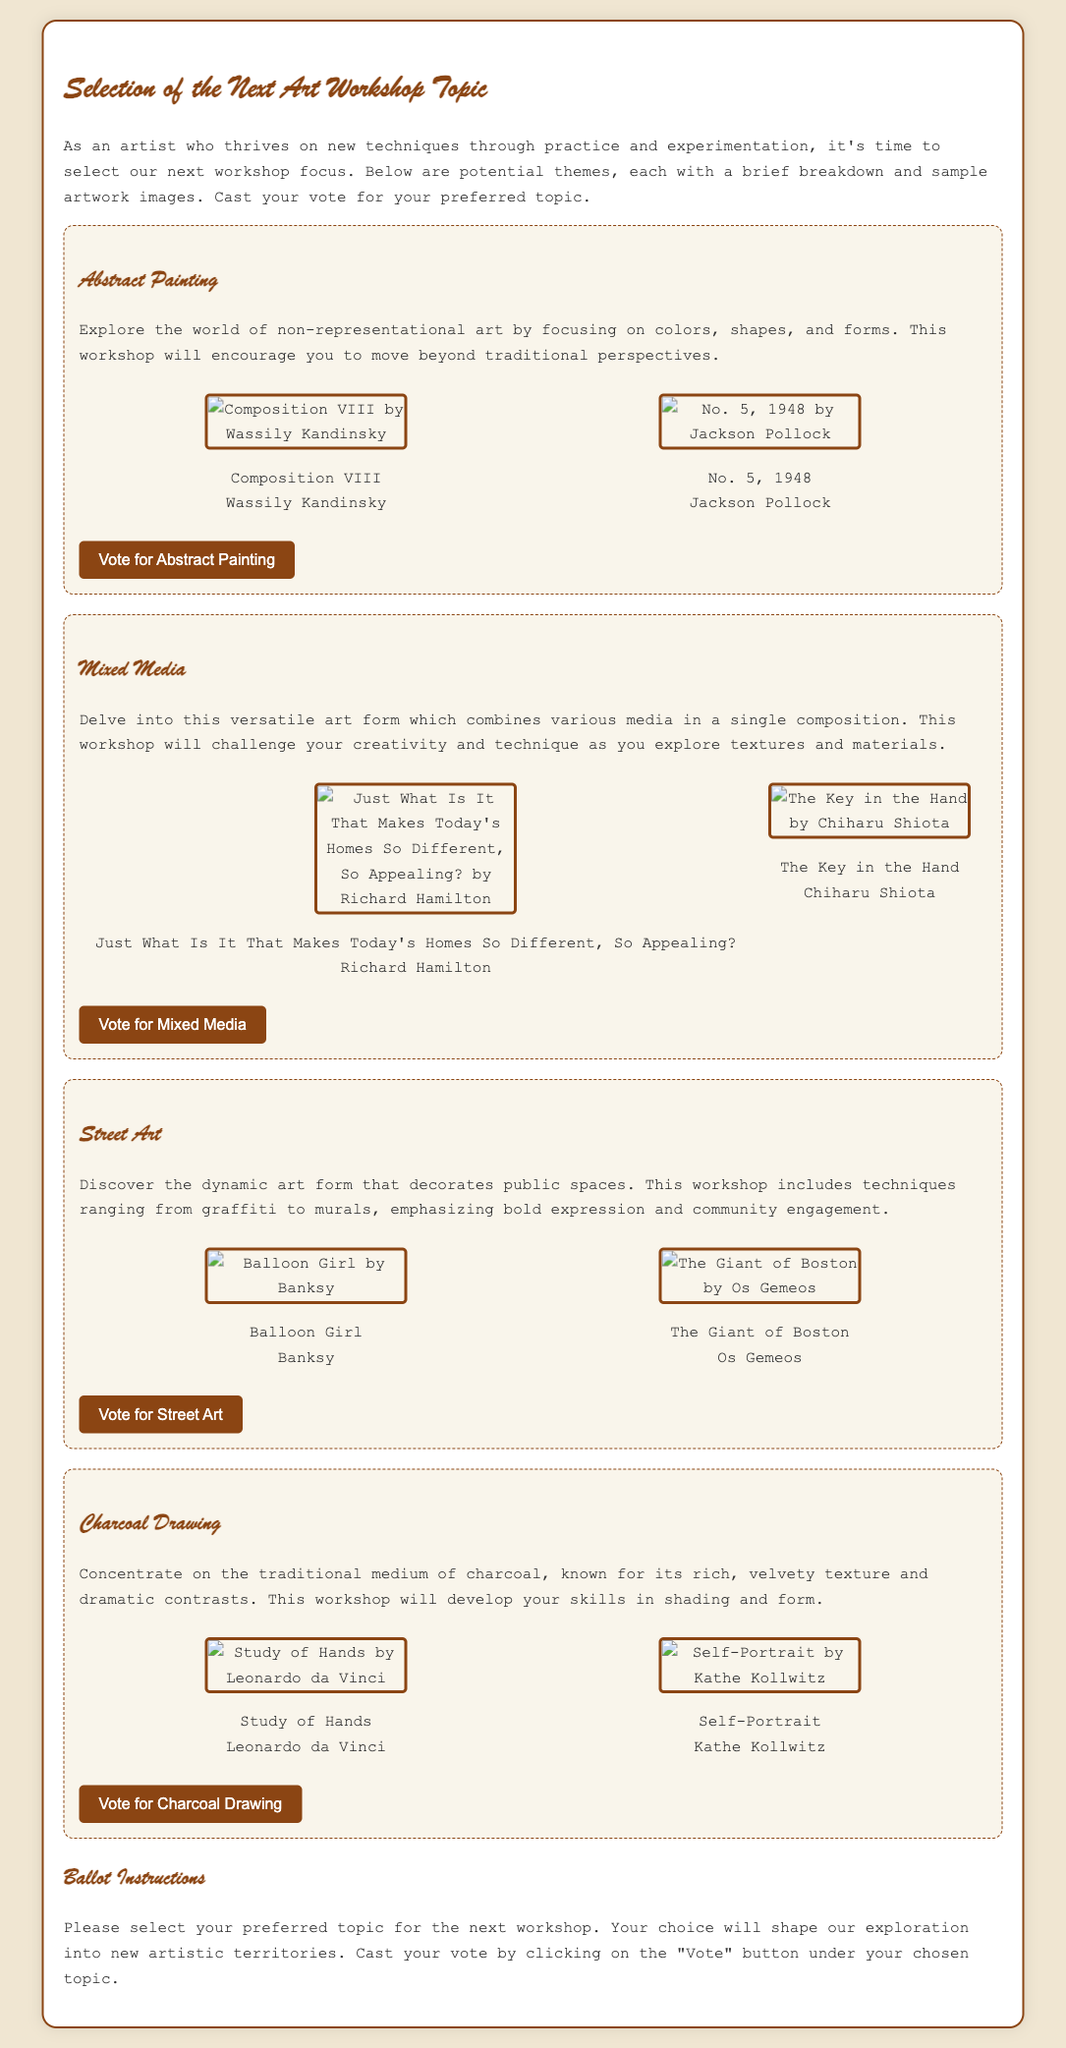What is the first workshop topic listed? The first workshop topic listed in the document is Abstract Painting, showcased prominently at the beginning of the topics section.
Answer: Abstract Painting How many sample artworks are shown for each topic? Each workshop topic features two sample artworks to illustrate the theme of the workshop, as seen in the layout of the document.
Answer: Two Who is the artist of "Composition VIII"? The artist of "Composition VIII" is Wassily Kandinsky, mentioned directly under the image in the sample art section.
Answer: Wassily Kandinsky What medium is the focus of the Charcoal Drawing workshop? The Charcoal Drawing workshop specifically focuses on the traditional medium of charcoal, which is indicated in the description of that topic.
Answer: Charcoal What is one technique to be explored in the Street Art workshop? The Street Art workshop will involve techniques ranging from graffiti to murals, highlighting the diverse expressions in public spaces.
Answer: Graffiti How does the document suggest participants cast their vote? Participants are instructed to cast their vote by clicking on the "Vote" button under their chosen topic, as outlined in the ballot instructions.
Answer: Click on the "Vote" button What color scheme is used for the document's background? The document features a soft beige color scheme for the background, creating a warm and inviting atmosphere for the reader.
Answer: Beige What is the primary purpose of this document? The primary purpose of the document is to facilitate the selection of the next art workshop topic through a voting process among participants.
Answer: Selection of the next art workshop topic 